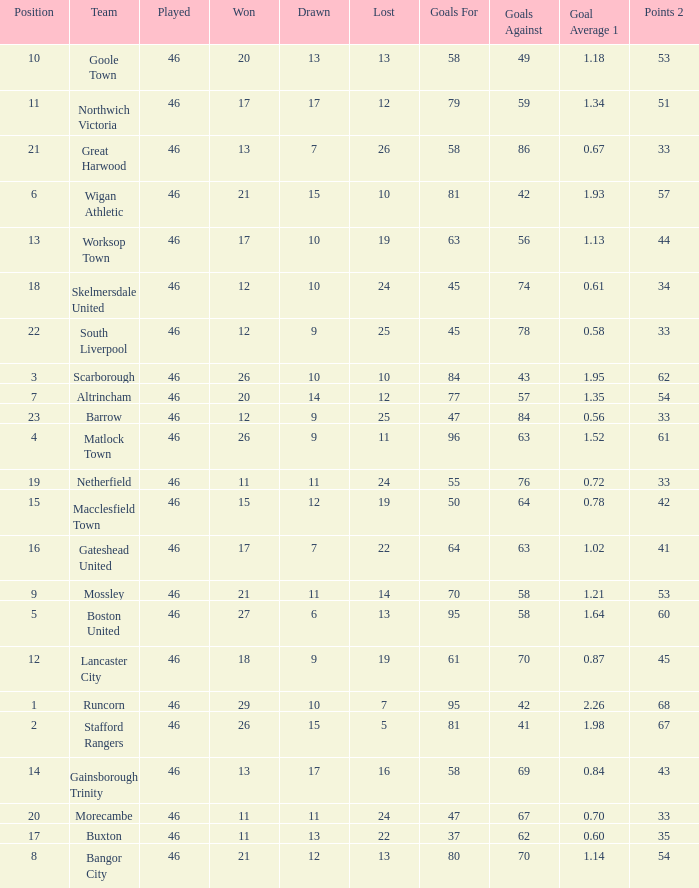How many times did the Lancaster City team play? 1.0. 